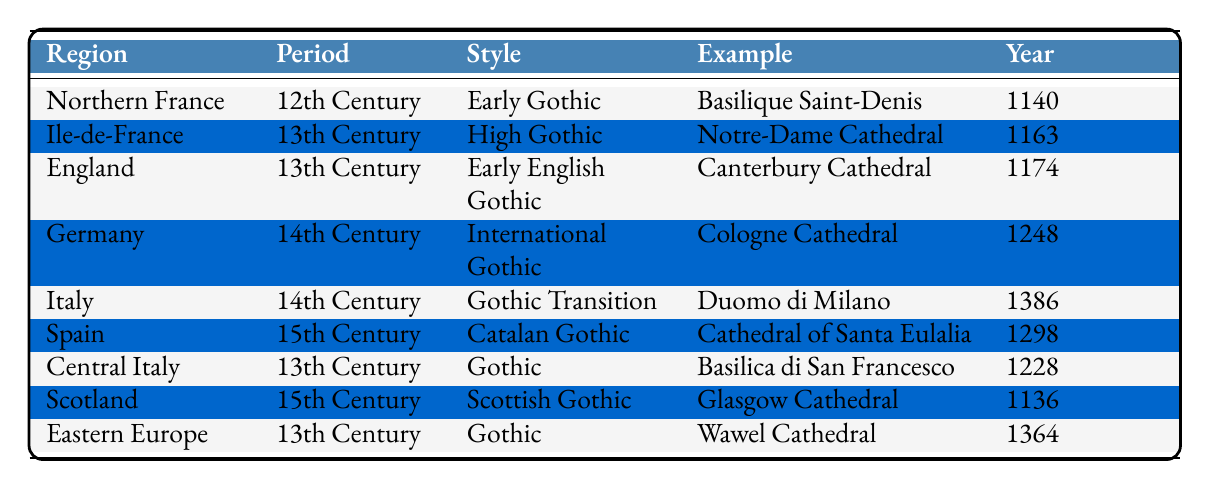What Gothic style is associated with the Basilica Saint-Denis? The table shows that the Basilica Saint-Denis is located in Northern France and is classified under the Early Gothic style.
Answer: Early Gothic Which city is associated with the Cathedral of Santa Eulalia? According to the table, the Cathedral of Santa Eulalia is located in Barcelona, Spain.
Answer: Barcelona How many Gothic styles from the 13th Century are listed in the table? The table identifies three styles from the 13th Century: High Gothic, Early English Gothic, and Gothic. Therefore, the total is three.
Answer: 3 What is the year of construction for the Duomo di Milano? The table specifies that the Duomo di Milano was constructed starting in the year 1386.
Answer: 1386 Is there any Gothic architectural style mentioned from the 14th Century? Yes, the table indicates several examples from the 14th Century, including International Gothic and Gothic Transition styles.
Answer: Yes Which Gothic style has examples from both England and France? The Early Gothic style is noted in the table for the Basilica Saint-Denis in France and the Early English Gothic style for Canterbury Cathedral in England, hence they relate through their chronological development.
Answer: Early Gothic Which regions have Gothic styles comprising examples in the 15th Century? The table lists Scottish Gothic for Scotland and Catalan Gothic for Spain, both of which are from the 15th Century. Therefore, the total number of regions is two.
Answer: 2 Was Wawel Cathedral built before or after the 15th Century? The table states that Wawel Cathedral was built in 1364, which is before the 15th Century.
Answer: Before Which Gothic style is the latest in terms of year of construction? The latest style mentioned in the table is Gothic Transition with the Duomo di Milano, built in 1386, as it has the highest year listed.
Answer: Gothic Transition How many structures are there in the 12th Century Gothic styles according to the table? The table shows only one structure listed in the 12th Century, which is the Basilica Saint-Denis.
Answer: 1 